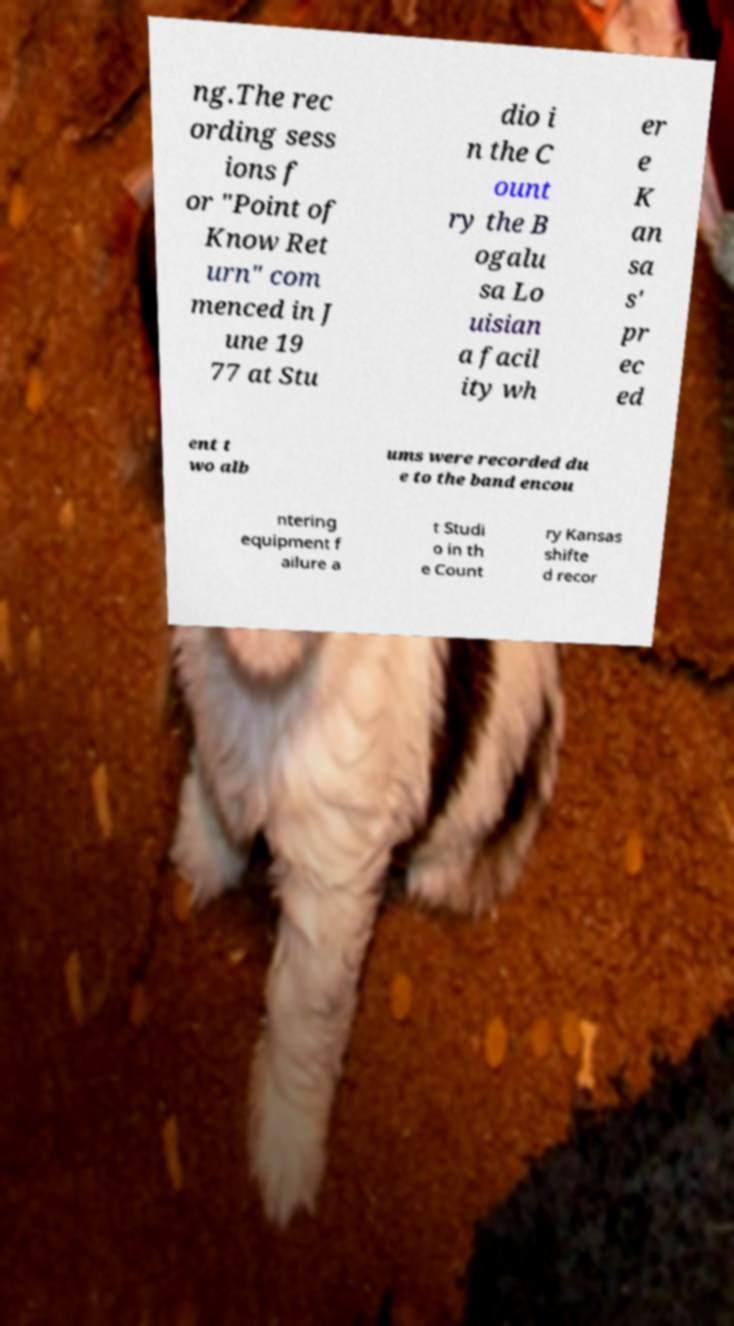Can you accurately transcribe the text from the provided image for me? ng.The rec ording sess ions f or "Point of Know Ret urn" com menced in J une 19 77 at Stu dio i n the C ount ry the B ogalu sa Lo uisian a facil ity wh er e K an sa s' pr ec ed ent t wo alb ums were recorded du e to the band encou ntering equipment f ailure a t Studi o in th e Count ry Kansas shifte d recor 